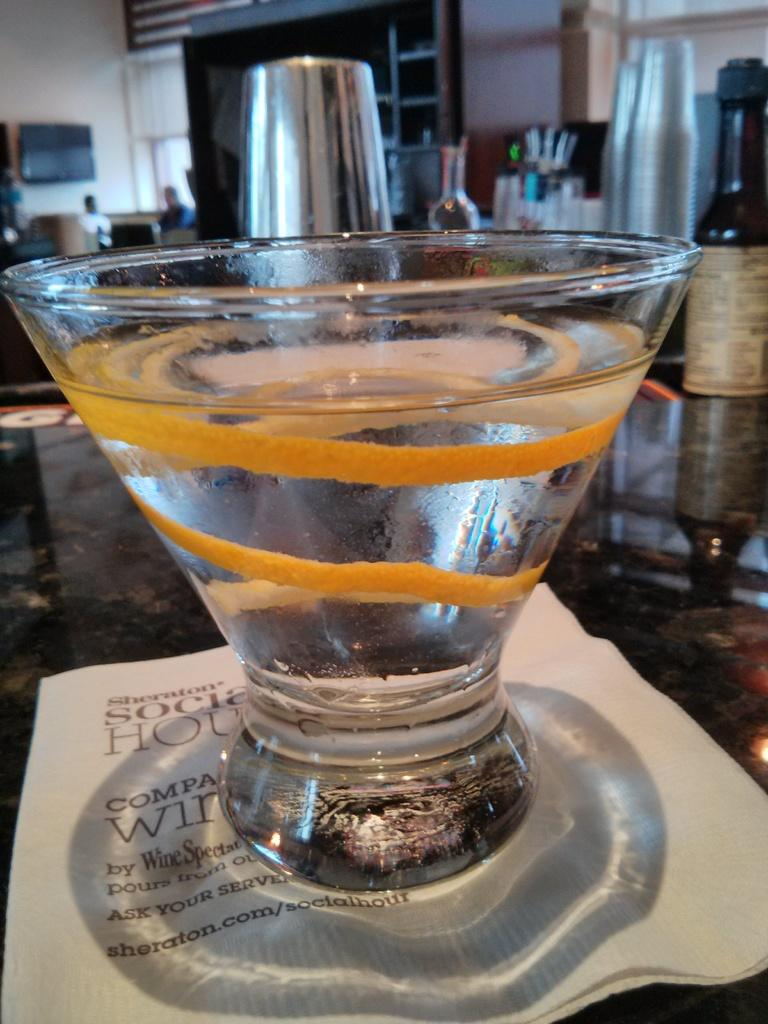What type of container is visible in the image? There is a glass and a bottle in the image. Can you describe the people in the image? There are people in the image, but their specific characteristics are not mentioned. What type of electronic device is present in the image? There is a television in the image. What type of furniture is present in the image? There is a rack and a table in the image. Are there any other objects in the image that are not specified? Yes, there are unspecified objects in the image. What type of sack is being used for the vacation in the image? There is no mention of a vacation or a sack in the image. What decision is being made by the people in the image? The specific actions or decisions of the people in the image are not mentioned. 